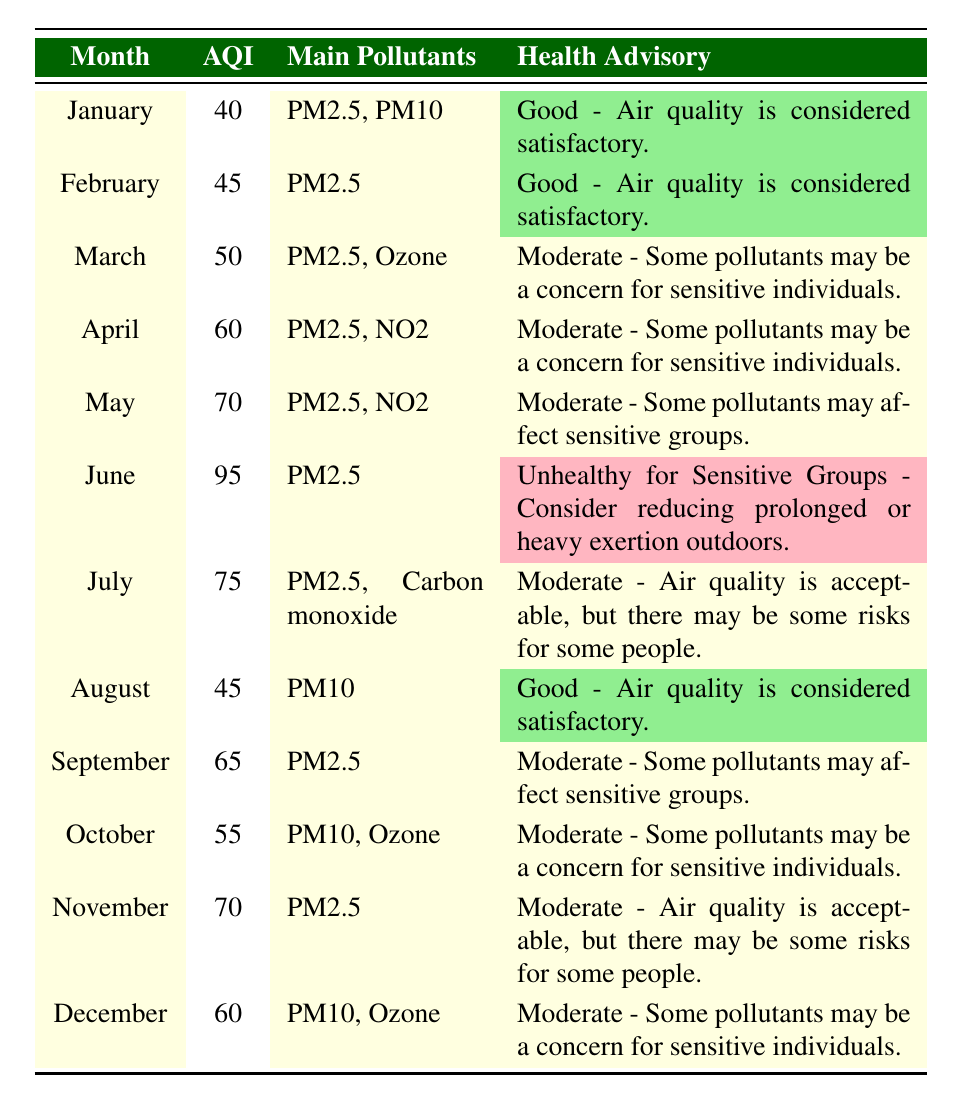What was the average AQI in Singapore in June 2022? The table indicates that the average AQI in June was 95.
Answer: 95 Which month had the highest average AQI? Upon reviewing the table, June has the highest average AQI value at 95, more than any other month.
Answer: June Was the air quality considered "Good" in August 2022? The table shows that the average AQI in August was 45, which falls under the "Good" category of air quality.
Answer: Yes What are the main pollutants for the month with the lowest average AQI? January has the lowest average AQI at 40, with main pollutants reported as PM2.5 and PM10 according to the table.
Answer: PM2.5, PM10 Calculate the average AQI for the first half of the year (January to June). The average AQI from January to June can be calculated as follows: (40 + 45 + 50 + 60 + 70 + 95) = 360. The number of months is 6, giving an average of 360/6 = 60.
Answer: 60 Is there a month in which the main pollutant was Carbon monoxide? By examining the table, July is the only month where Carbon monoxide was listed as a main pollutant along with PM2.5.
Answer: Yes How many months had an average AQI classified as "Moderate"? The months classified as "Moderate" are March, April, May, July, September, October, November, and December. This totals to 8 months.
Answer: 8 In what month was the health advisory "Unhealthy for Sensitive Groups" issued? The table explicitly states that the health advisory "Unhealthy for Sensitive Groups" was issued in June 2022.
Answer: June What is the difference in average AQI between the best month (January) and the worst month (June)? January has an average AQI of 40 and June has an average AQI of 95. The difference is calculated as 95 - 40 = 55.
Answer: 55 